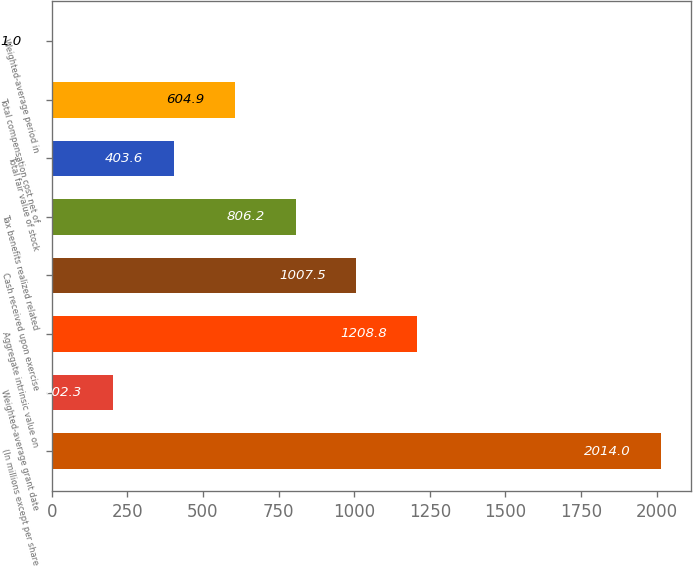Convert chart to OTSL. <chart><loc_0><loc_0><loc_500><loc_500><bar_chart><fcel>(In millions except per share<fcel>Weighted-average grant date<fcel>Aggregate intrinsic value on<fcel>Cash received upon exercise<fcel>Tax benefits realized related<fcel>Total fair value of stock<fcel>Total compensation cost net of<fcel>Weighted-average period in<nl><fcel>2014<fcel>202.3<fcel>1208.8<fcel>1007.5<fcel>806.2<fcel>403.6<fcel>604.9<fcel>1<nl></chart> 